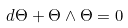Convert formula to latex. <formula><loc_0><loc_0><loc_500><loc_500>d \Theta + \Theta \wedge \Theta = 0</formula> 